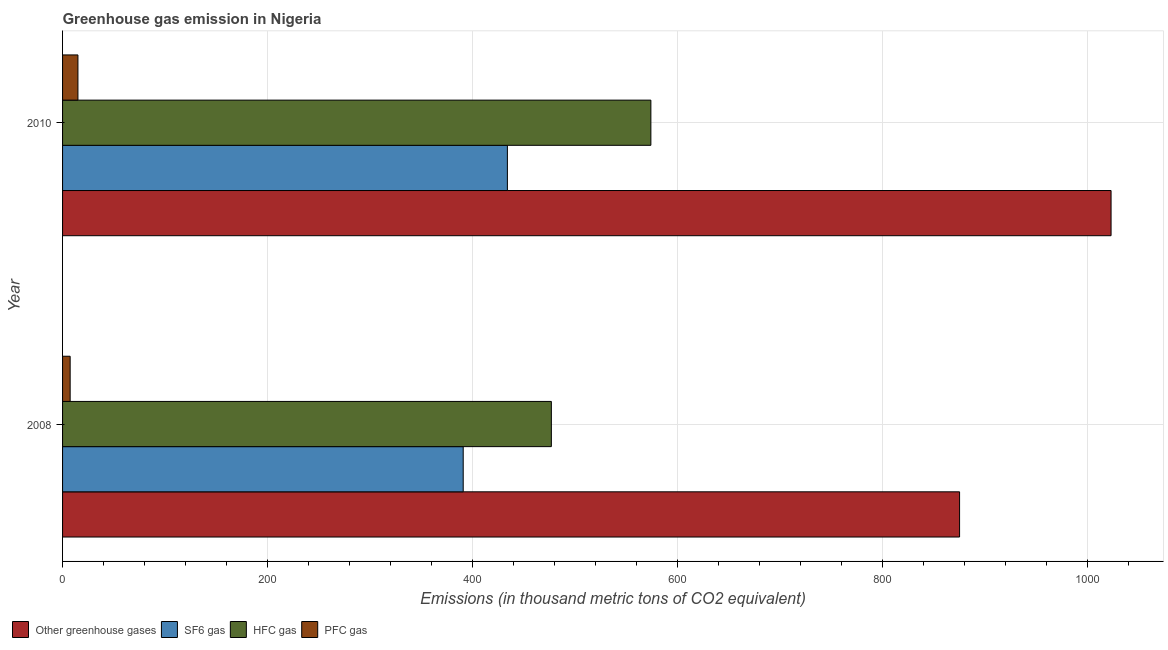How many different coloured bars are there?
Ensure brevity in your answer.  4. How many groups of bars are there?
Provide a short and direct response. 2. Are the number of bars on each tick of the Y-axis equal?
Your response must be concise. Yes. How many bars are there on the 2nd tick from the top?
Offer a very short reply. 4. How many bars are there on the 1st tick from the bottom?
Provide a short and direct response. 4. What is the emission of hfc gas in 2008?
Ensure brevity in your answer.  476.9. Across all years, what is the maximum emission of hfc gas?
Make the answer very short. 574. Across all years, what is the minimum emission of greenhouse gases?
Your answer should be very brief. 875.2. In which year was the emission of sf6 gas maximum?
Offer a very short reply. 2010. What is the total emission of pfc gas in the graph?
Provide a short and direct response. 22.4. What is the difference between the emission of sf6 gas in 2008 and that in 2010?
Your answer should be compact. -43.1. What is the difference between the emission of greenhouse gases in 2010 and the emission of hfc gas in 2008?
Provide a short and direct response. 546.1. What is the average emission of pfc gas per year?
Your answer should be very brief. 11.2. In the year 2008, what is the difference between the emission of sf6 gas and emission of pfc gas?
Your response must be concise. 383.5. In how many years, is the emission of greenhouse gases greater than 800 thousand metric tons?
Your answer should be very brief. 2. What is the ratio of the emission of hfc gas in 2008 to that in 2010?
Ensure brevity in your answer.  0.83. In how many years, is the emission of sf6 gas greater than the average emission of sf6 gas taken over all years?
Give a very brief answer. 1. What does the 3rd bar from the top in 2010 represents?
Offer a terse response. SF6 gas. What does the 2nd bar from the bottom in 2010 represents?
Offer a terse response. SF6 gas. Is it the case that in every year, the sum of the emission of greenhouse gases and emission of sf6 gas is greater than the emission of hfc gas?
Your answer should be compact. Yes. Are all the bars in the graph horizontal?
Ensure brevity in your answer.  Yes. What is the difference between two consecutive major ticks on the X-axis?
Offer a very short reply. 200. Are the values on the major ticks of X-axis written in scientific E-notation?
Your answer should be compact. No. How many legend labels are there?
Offer a terse response. 4. What is the title of the graph?
Offer a very short reply. Greenhouse gas emission in Nigeria. What is the label or title of the X-axis?
Offer a terse response. Emissions (in thousand metric tons of CO2 equivalent). What is the Emissions (in thousand metric tons of CO2 equivalent) of Other greenhouse gases in 2008?
Give a very brief answer. 875.2. What is the Emissions (in thousand metric tons of CO2 equivalent) of SF6 gas in 2008?
Your answer should be compact. 390.9. What is the Emissions (in thousand metric tons of CO2 equivalent) in HFC gas in 2008?
Ensure brevity in your answer.  476.9. What is the Emissions (in thousand metric tons of CO2 equivalent) of PFC gas in 2008?
Offer a very short reply. 7.4. What is the Emissions (in thousand metric tons of CO2 equivalent) in Other greenhouse gases in 2010?
Your response must be concise. 1023. What is the Emissions (in thousand metric tons of CO2 equivalent) in SF6 gas in 2010?
Ensure brevity in your answer.  434. What is the Emissions (in thousand metric tons of CO2 equivalent) of HFC gas in 2010?
Ensure brevity in your answer.  574. Across all years, what is the maximum Emissions (in thousand metric tons of CO2 equivalent) in Other greenhouse gases?
Your answer should be very brief. 1023. Across all years, what is the maximum Emissions (in thousand metric tons of CO2 equivalent) of SF6 gas?
Your answer should be very brief. 434. Across all years, what is the maximum Emissions (in thousand metric tons of CO2 equivalent) of HFC gas?
Provide a succinct answer. 574. Across all years, what is the minimum Emissions (in thousand metric tons of CO2 equivalent) in Other greenhouse gases?
Offer a very short reply. 875.2. Across all years, what is the minimum Emissions (in thousand metric tons of CO2 equivalent) of SF6 gas?
Your response must be concise. 390.9. Across all years, what is the minimum Emissions (in thousand metric tons of CO2 equivalent) of HFC gas?
Make the answer very short. 476.9. What is the total Emissions (in thousand metric tons of CO2 equivalent) in Other greenhouse gases in the graph?
Your answer should be compact. 1898.2. What is the total Emissions (in thousand metric tons of CO2 equivalent) in SF6 gas in the graph?
Keep it short and to the point. 824.9. What is the total Emissions (in thousand metric tons of CO2 equivalent) of HFC gas in the graph?
Give a very brief answer. 1050.9. What is the total Emissions (in thousand metric tons of CO2 equivalent) of PFC gas in the graph?
Give a very brief answer. 22.4. What is the difference between the Emissions (in thousand metric tons of CO2 equivalent) of Other greenhouse gases in 2008 and that in 2010?
Offer a very short reply. -147.8. What is the difference between the Emissions (in thousand metric tons of CO2 equivalent) in SF6 gas in 2008 and that in 2010?
Keep it short and to the point. -43.1. What is the difference between the Emissions (in thousand metric tons of CO2 equivalent) in HFC gas in 2008 and that in 2010?
Offer a very short reply. -97.1. What is the difference between the Emissions (in thousand metric tons of CO2 equivalent) in Other greenhouse gases in 2008 and the Emissions (in thousand metric tons of CO2 equivalent) in SF6 gas in 2010?
Your answer should be compact. 441.2. What is the difference between the Emissions (in thousand metric tons of CO2 equivalent) of Other greenhouse gases in 2008 and the Emissions (in thousand metric tons of CO2 equivalent) of HFC gas in 2010?
Keep it short and to the point. 301.2. What is the difference between the Emissions (in thousand metric tons of CO2 equivalent) in Other greenhouse gases in 2008 and the Emissions (in thousand metric tons of CO2 equivalent) in PFC gas in 2010?
Your response must be concise. 860.2. What is the difference between the Emissions (in thousand metric tons of CO2 equivalent) in SF6 gas in 2008 and the Emissions (in thousand metric tons of CO2 equivalent) in HFC gas in 2010?
Offer a very short reply. -183.1. What is the difference between the Emissions (in thousand metric tons of CO2 equivalent) in SF6 gas in 2008 and the Emissions (in thousand metric tons of CO2 equivalent) in PFC gas in 2010?
Your response must be concise. 375.9. What is the difference between the Emissions (in thousand metric tons of CO2 equivalent) of HFC gas in 2008 and the Emissions (in thousand metric tons of CO2 equivalent) of PFC gas in 2010?
Give a very brief answer. 461.9. What is the average Emissions (in thousand metric tons of CO2 equivalent) in Other greenhouse gases per year?
Provide a short and direct response. 949.1. What is the average Emissions (in thousand metric tons of CO2 equivalent) of SF6 gas per year?
Your answer should be compact. 412.45. What is the average Emissions (in thousand metric tons of CO2 equivalent) in HFC gas per year?
Your answer should be compact. 525.45. In the year 2008, what is the difference between the Emissions (in thousand metric tons of CO2 equivalent) of Other greenhouse gases and Emissions (in thousand metric tons of CO2 equivalent) of SF6 gas?
Your response must be concise. 484.3. In the year 2008, what is the difference between the Emissions (in thousand metric tons of CO2 equivalent) in Other greenhouse gases and Emissions (in thousand metric tons of CO2 equivalent) in HFC gas?
Make the answer very short. 398.3. In the year 2008, what is the difference between the Emissions (in thousand metric tons of CO2 equivalent) of Other greenhouse gases and Emissions (in thousand metric tons of CO2 equivalent) of PFC gas?
Offer a terse response. 867.8. In the year 2008, what is the difference between the Emissions (in thousand metric tons of CO2 equivalent) of SF6 gas and Emissions (in thousand metric tons of CO2 equivalent) of HFC gas?
Your answer should be compact. -86. In the year 2008, what is the difference between the Emissions (in thousand metric tons of CO2 equivalent) in SF6 gas and Emissions (in thousand metric tons of CO2 equivalent) in PFC gas?
Your response must be concise. 383.5. In the year 2008, what is the difference between the Emissions (in thousand metric tons of CO2 equivalent) of HFC gas and Emissions (in thousand metric tons of CO2 equivalent) of PFC gas?
Your answer should be compact. 469.5. In the year 2010, what is the difference between the Emissions (in thousand metric tons of CO2 equivalent) in Other greenhouse gases and Emissions (in thousand metric tons of CO2 equivalent) in SF6 gas?
Offer a very short reply. 589. In the year 2010, what is the difference between the Emissions (in thousand metric tons of CO2 equivalent) in Other greenhouse gases and Emissions (in thousand metric tons of CO2 equivalent) in HFC gas?
Your answer should be compact. 449. In the year 2010, what is the difference between the Emissions (in thousand metric tons of CO2 equivalent) in Other greenhouse gases and Emissions (in thousand metric tons of CO2 equivalent) in PFC gas?
Keep it short and to the point. 1008. In the year 2010, what is the difference between the Emissions (in thousand metric tons of CO2 equivalent) in SF6 gas and Emissions (in thousand metric tons of CO2 equivalent) in HFC gas?
Your response must be concise. -140. In the year 2010, what is the difference between the Emissions (in thousand metric tons of CO2 equivalent) of SF6 gas and Emissions (in thousand metric tons of CO2 equivalent) of PFC gas?
Offer a terse response. 419. In the year 2010, what is the difference between the Emissions (in thousand metric tons of CO2 equivalent) of HFC gas and Emissions (in thousand metric tons of CO2 equivalent) of PFC gas?
Offer a very short reply. 559. What is the ratio of the Emissions (in thousand metric tons of CO2 equivalent) in Other greenhouse gases in 2008 to that in 2010?
Your response must be concise. 0.86. What is the ratio of the Emissions (in thousand metric tons of CO2 equivalent) of SF6 gas in 2008 to that in 2010?
Ensure brevity in your answer.  0.9. What is the ratio of the Emissions (in thousand metric tons of CO2 equivalent) of HFC gas in 2008 to that in 2010?
Your response must be concise. 0.83. What is the ratio of the Emissions (in thousand metric tons of CO2 equivalent) in PFC gas in 2008 to that in 2010?
Make the answer very short. 0.49. What is the difference between the highest and the second highest Emissions (in thousand metric tons of CO2 equivalent) in Other greenhouse gases?
Offer a very short reply. 147.8. What is the difference between the highest and the second highest Emissions (in thousand metric tons of CO2 equivalent) in SF6 gas?
Provide a succinct answer. 43.1. What is the difference between the highest and the second highest Emissions (in thousand metric tons of CO2 equivalent) of HFC gas?
Make the answer very short. 97.1. What is the difference between the highest and the second highest Emissions (in thousand metric tons of CO2 equivalent) in PFC gas?
Your response must be concise. 7.6. What is the difference between the highest and the lowest Emissions (in thousand metric tons of CO2 equivalent) in Other greenhouse gases?
Your response must be concise. 147.8. What is the difference between the highest and the lowest Emissions (in thousand metric tons of CO2 equivalent) of SF6 gas?
Your answer should be compact. 43.1. What is the difference between the highest and the lowest Emissions (in thousand metric tons of CO2 equivalent) in HFC gas?
Give a very brief answer. 97.1. What is the difference between the highest and the lowest Emissions (in thousand metric tons of CO2 equivalent) in PFC gas?
Provide a short and direct response. 7.6. 